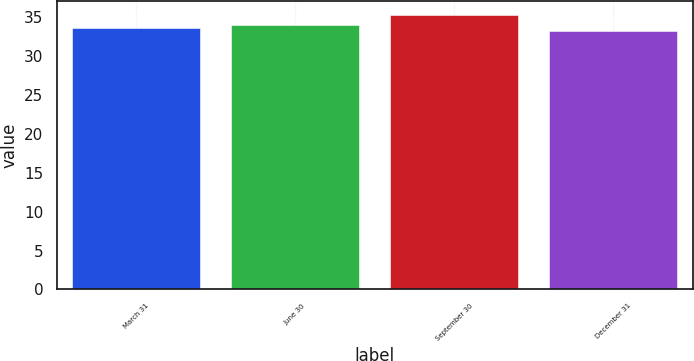<chart> <loc_0><loc_0><loc_500><loc_500><bar_chart><fcel>March 31<fcel>June 30<fcel>September 30<fcel>December 31<nl><fcel>33.68<fcel>34.04<fcel>35.3<fcel>33.21<nl></chart> 